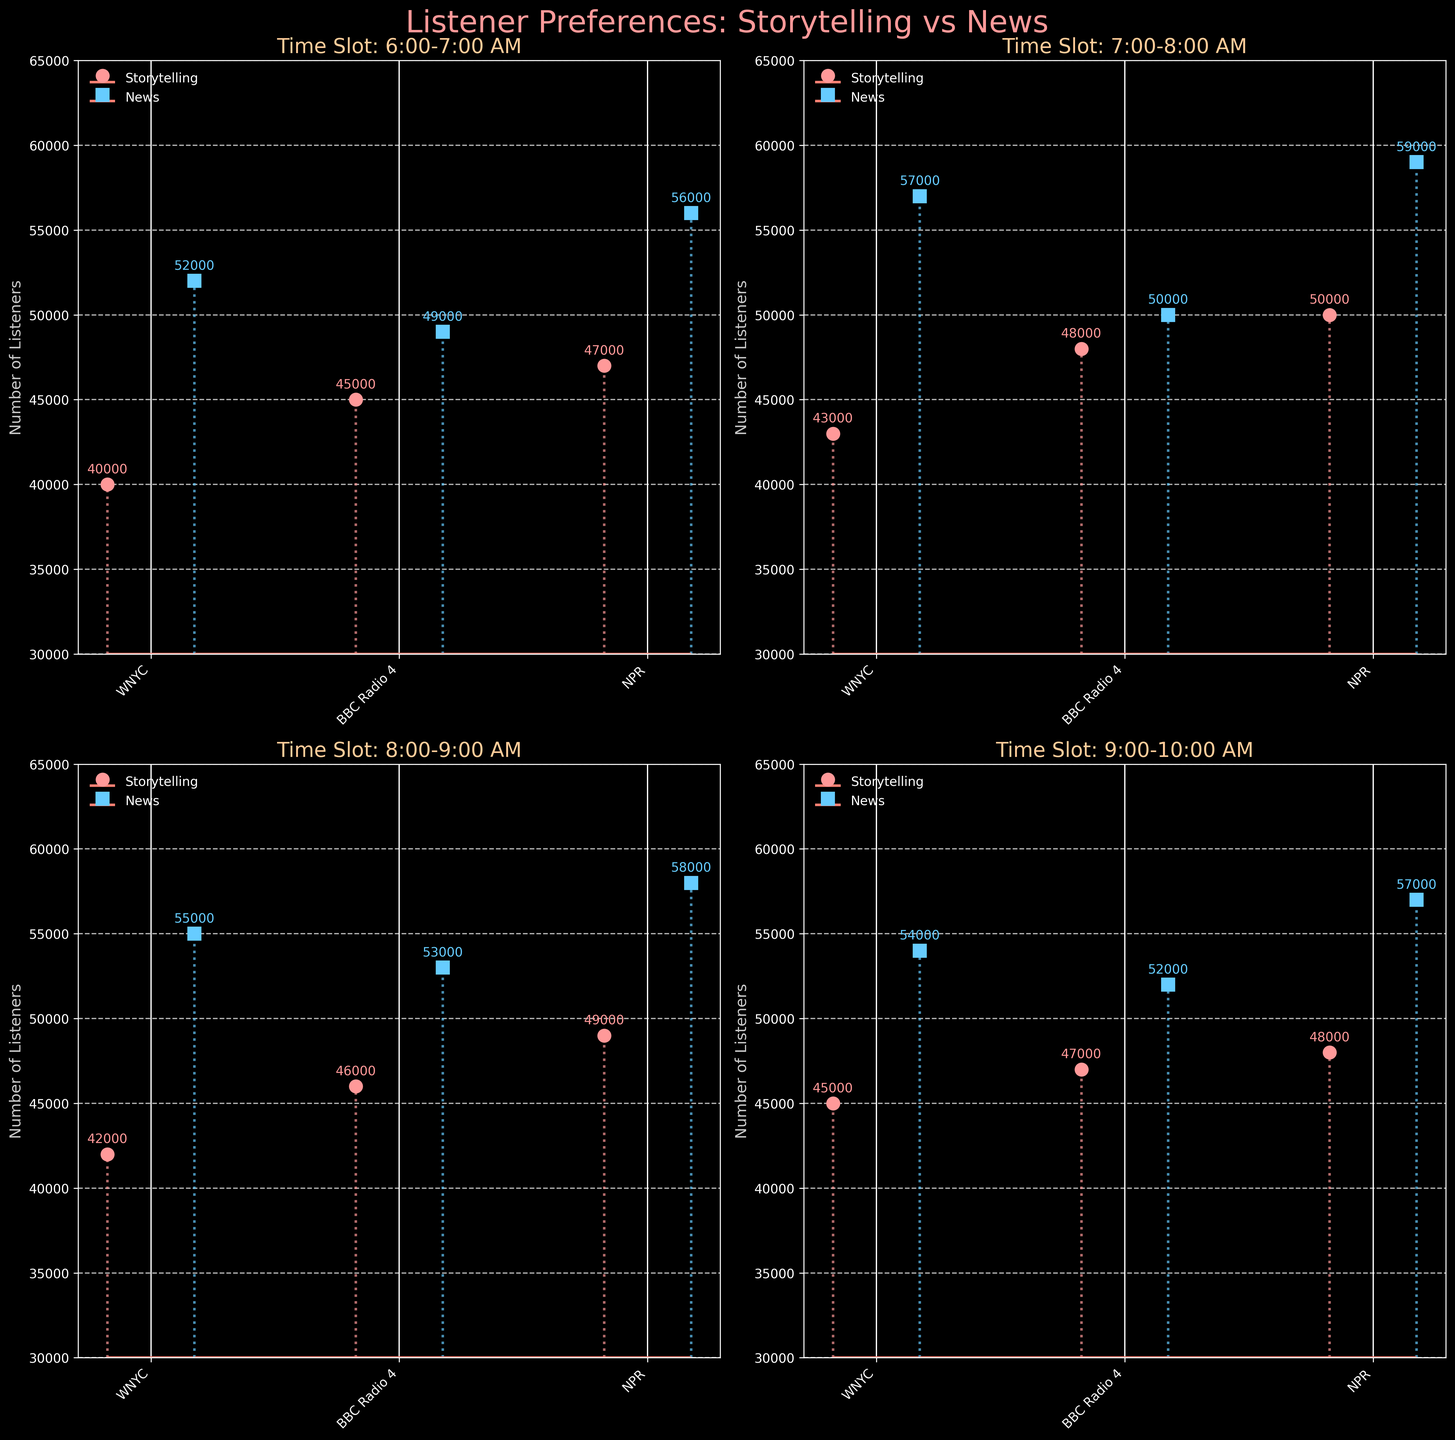What is the overall title of the figure? The overall title of the figure is prominently displayed at the top and reads "Listener Preferences: Storytelling vs News".
Answer: Listener Preferences: Storytelling vs News How many radio programs are compared in each subplot? Looking at any subplot, you can see that the x-axis shows three distinct labels representing three different radio stations. Therefore, each subplot compares three radio programs.
Answer: Three Which time slot subplot shows the highest number of listeners for storytelling segments? By examining the numerical values on top of the columns representing storytelling segments in each subplot, we can see that the highest value is 50000, which appears in the 7:00-8:00 AM slot for NPR.
Answer: 7:00-8:00 AM Between WNYC and NPR, which station has more listeners for news segments during the 8:00-9:00 AM slot? The subplot for the 8:00-9:00 AM slot shows that WNYC has 55000 listeners, and NPR has 58000 listeners for news segments. Since 58000 > 55000, NPR has more listeners.
Answer: NPR What's the color used for the markers representing storytelling segments? The color of the markers for storytelling segments across all subplots is consistently pink, as indicated by the circular markers and corresponding stemlines.
Answer: Pink What is the range of listeners for news segments across the entire figure? Checking all news segment values across the subplots, the lowest number is 49000 and the highest is 59000. Thus, the range is calculated by subtracting the minimum from the maximum: 59000 - 49000 = 10000.
Answer: 10000 Which station has the smallest difference between storytelling and news listeners during the 6:00-7:00 AM slot? Investigate the difference for each station in this slot: WNYC (52000 - 40000 = 12000), BBC Radio 4 (49000 - 45000 = 4000), NPR (56000 - 47000 = 9000). BBC Radio 4 has the smallest difference of 4000.
Answer: BBC Radio 4 In which time slot does WNYC have the least number of listeners for storytelling segments? Comparing the storytelling segment values for WNYC across all time slots, the 8:00-9:00 AM slot has the lowest number of 42000 listeners.
Answer: 8:00-9:00 AM What is the total number of listeners for news segments from NPR across all time slots? Sum the number of listeners for NPR's news segments across all slots: 56000 + 59000 + 58000 + 57000. The total is 56000 + 59000 + 58000 + 57000 = 230000.
Answer: 230000 